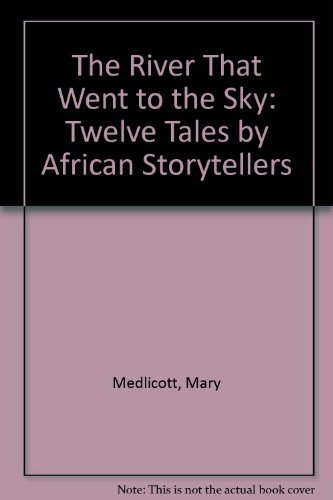What age group is this book intended for? The book is ideal for children aged 6 to 12 years, offering stories that are both enjoyable and suitable for their understanding and developmental stage. 